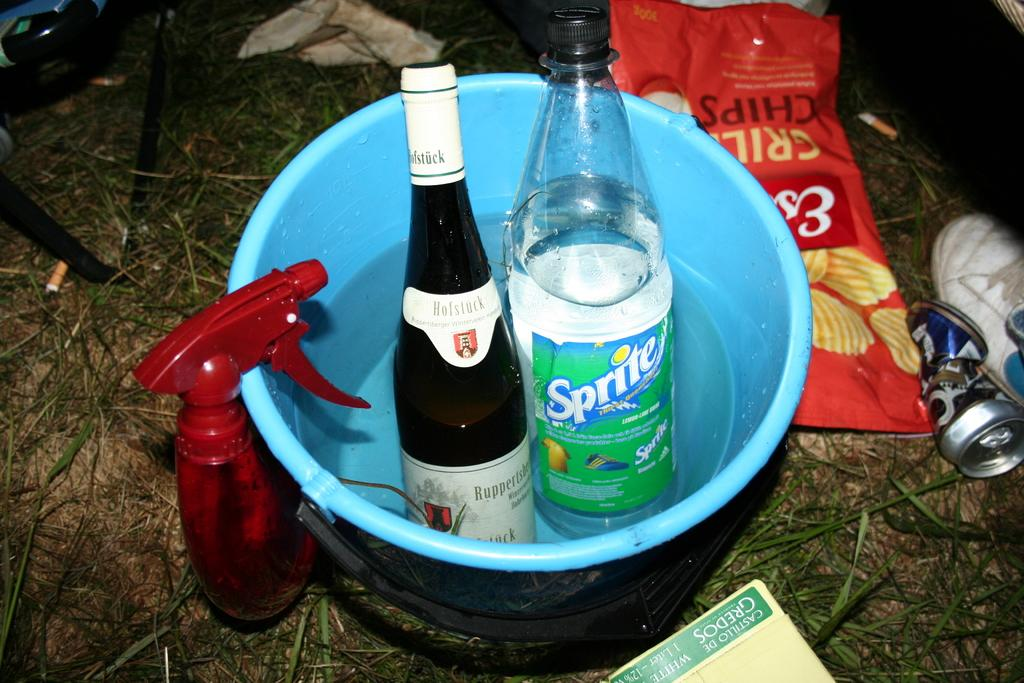How many bottles are in the bucket in the image? There are 2 bottles in a bucket full of water in the image. What other items can be seen near the bucket? There is a chips packet, a crushed tin, and a book beside the bucket. What type of skin can be seen on the meat in the image? There is no meat or skin present in the image; it features a bucket with 2 bottles and other items nearby. 